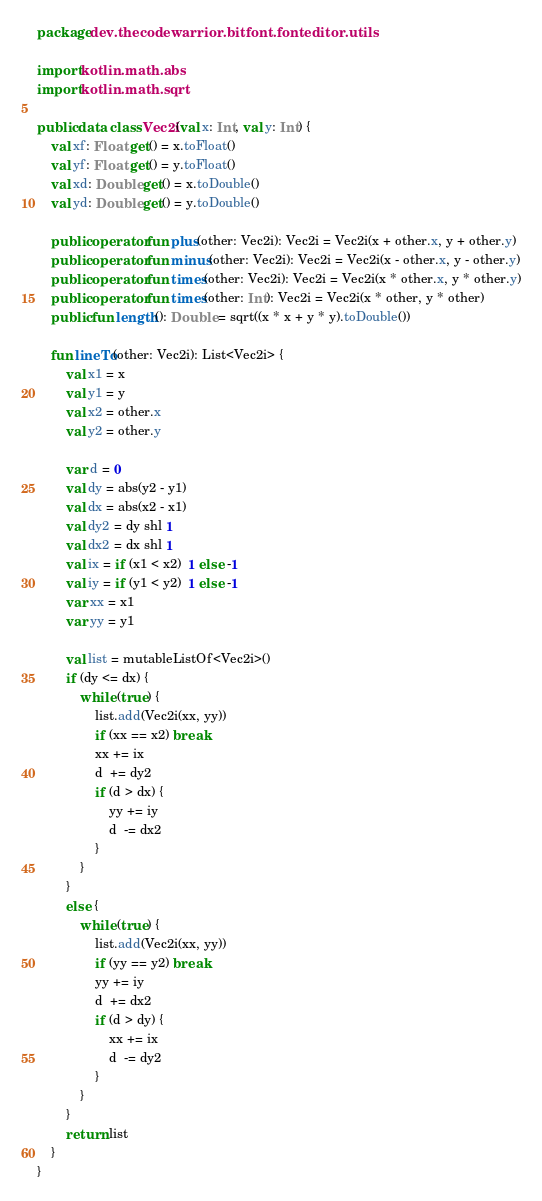<code> <loc_0><loc_0><loc_500><loc_500><_Kotlin_>package dev.thecodewarrior.bitfont.fonteditor.utils

import kotlin.math.abs
import kotlin.math.sqrt

public data class Vec2i(val x: Int, val y: Int) {
    val xf: Float get() = x.toFloat()
    val yf: Float get() = y.toFloat()
    val xd: Double get() = x.toDouble()
    val yd: Double get() = y.toDouble()

    public operator fun plus(other: Vec2i): Vec2i = Vec2i(x + other.x, y + other.y)
    public operator fun minus(other: Vec2i): Vec2i = Vec2i(x - other.x, y - other.y)
    public operator fun times(other: Vec2i): Vec2i = Vec2i(x * other.x, y * other.y)
    public operator fun times(other: Int): Vec2i = Vec2i(x * other, y * other)
    public fun length(): Double = sqrt((x * x + y * y).toDouble())

    fun lineTo(other: Vec2i): List<Vec2i> {
        val x1 = x
        val y1 = y
        val x2 = other.x
        val y2 = other.y

        var d = 0
        val dy = abs(y2 - y1)
        val dx = abs(x2 - x1)
        val dy2 = dy shl 1
        val dx2 = dx shl 1
        val ix = if (x1 < x2)  1 else -1
        val iy = if (y1 < y2)  1 else -1
        var xx = x1
        var yy = y1

        val list = mutableListOf<Vec2i>()
        if (dy <= dx) {
            while (true) {
                list.add(Vec2i(xx, yy))
                if (xx == x2) break
                xx += ix
                d  += dy2
                if (d > dx) {
                    yy += iy
                    d  -= dx2
                }
            }
        }
        else {
            while (true) {
                list.add(Vec2i(xx, yy))
                if (yy == y2) break
                yy += iy
                d  += dx2
                if (d > dy) {
                    xx += ix
                    d  -= dy2
                }
            }
        }
        return list
    }
}

</code> 